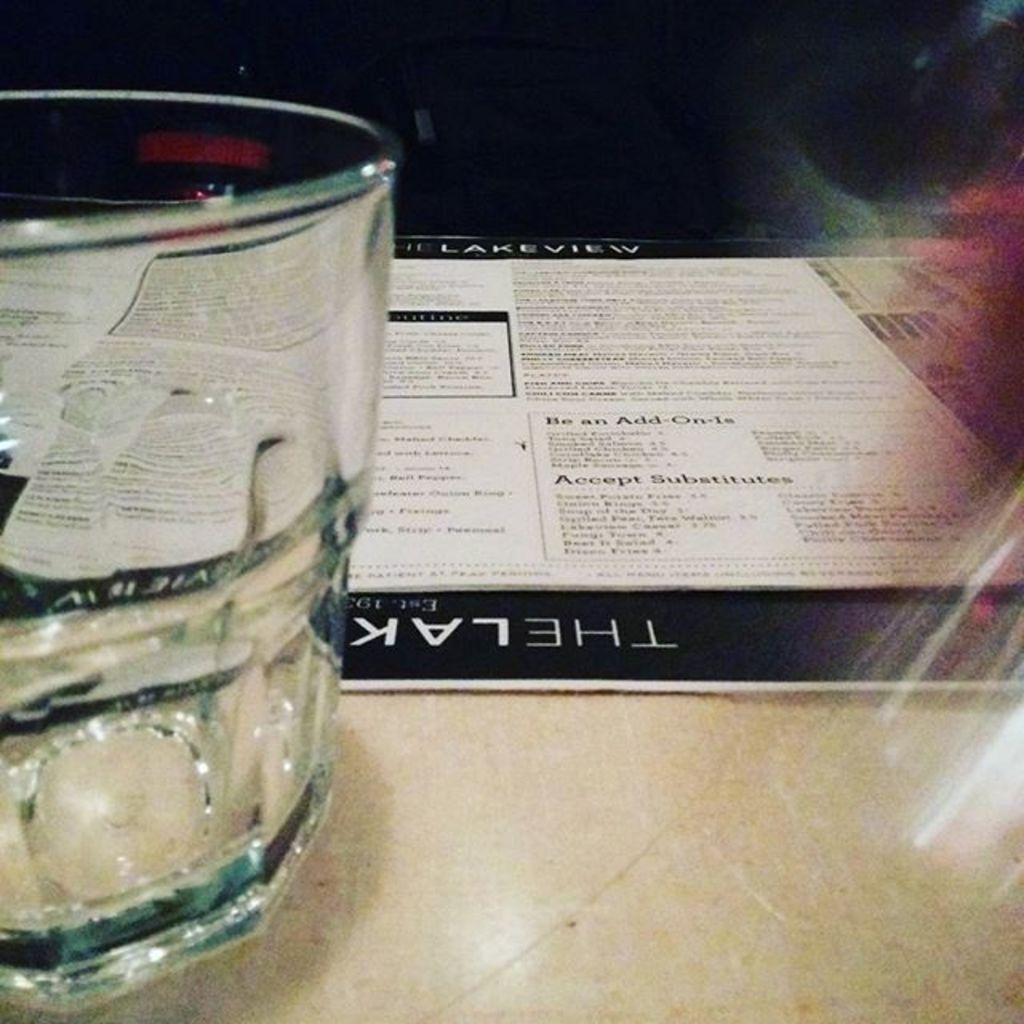<image>
Relay a brief, clear account of the picture shown. A menu for a restaurant called the Lakeview. 